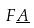Convert formula to latex. <formula><loc_0><loc_0><loc_500><loc_500>F \underline { A }</formula> 